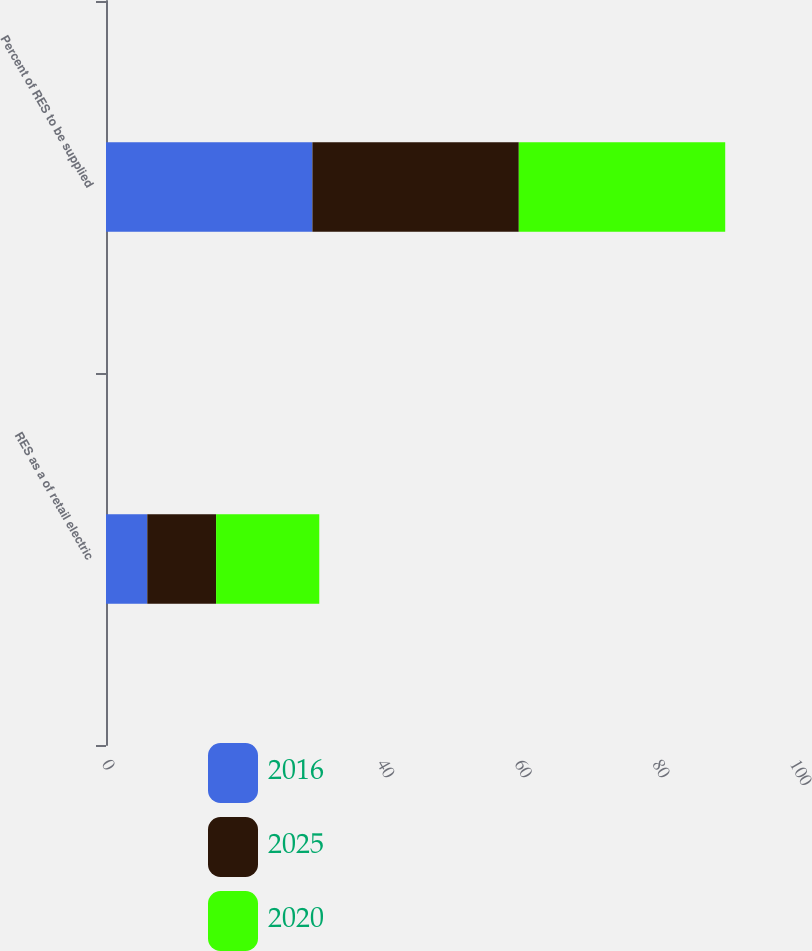Convert chart to OTSL. <chart><loc_0><loc_0><loc_500><loc_500><stacked_bar_chart><ecel><fcel>RES as a of retail electric<fcel>Percent of RES to be supplied<nl><fcel>2016<fcel>6<fcel>30<nl><fcel>2025<fcel>10<fcel>30<nl><fcel>2020<fcel>15<fcel>30<nl></chart> 